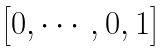Convert formula to latex. <formula><loc_0><loc_0><loc_500><loc_500>\begin{bmatrix} 0 , \cdots , 0 , 1 \end{bmatrix}</formula> 